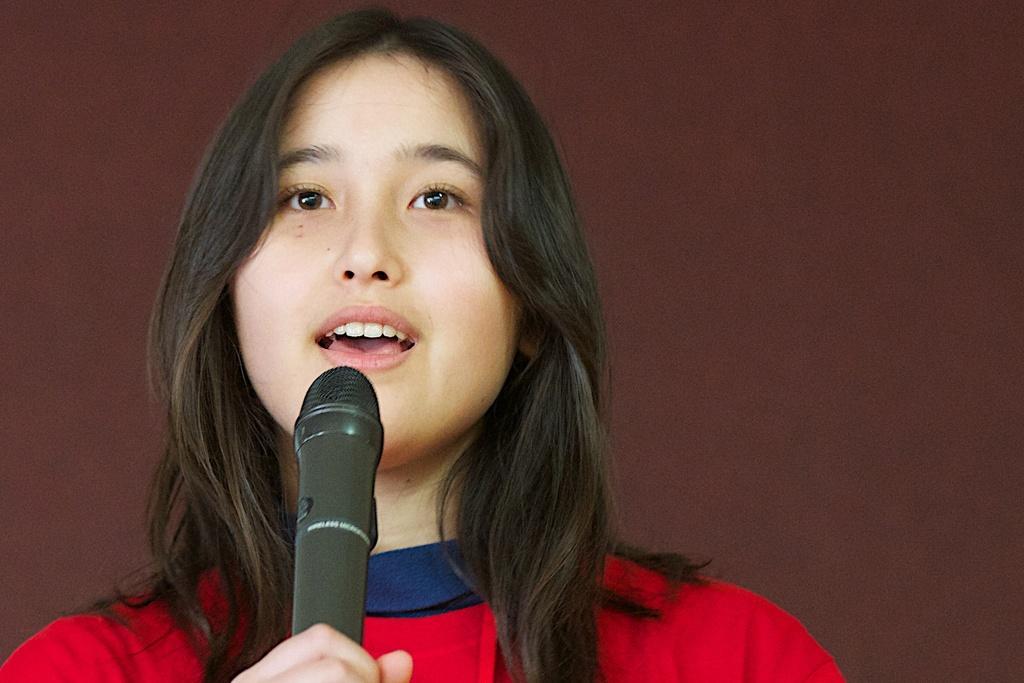Describe this image in one or two sentences. In the image we can see there is a girl who is standing and holding mic in her hand. 